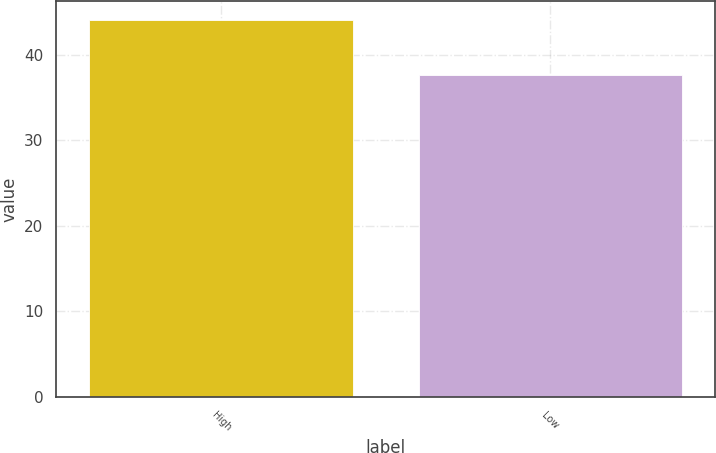Convert chart. <chart><loc_0><loc_0><loc_500><loc_500><bar_chart><fcel>High<fcel>Low<nl><fcel>44.06<fcel>37.61<nl></chart> 